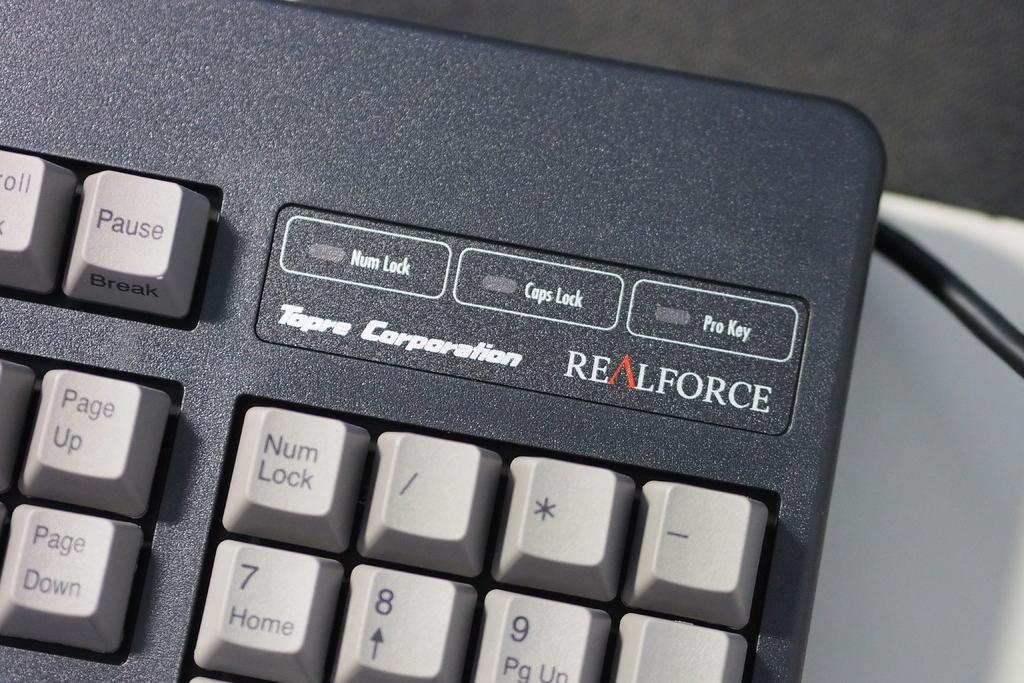Is this a realforce keyboard?
Your answer should be very brief. Yes. What is the brand of this keyboard?
Your response must be concise. Realforce. 